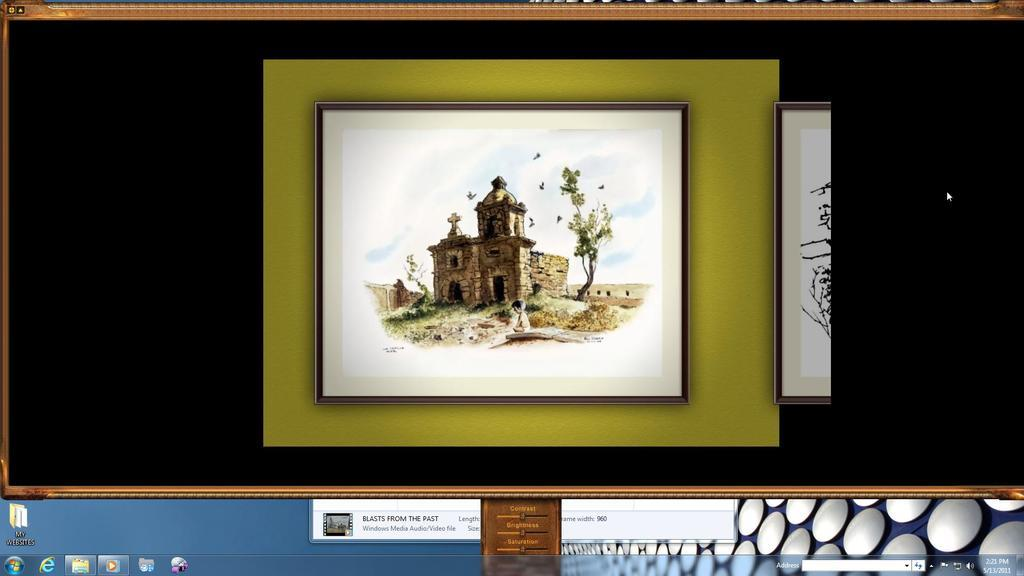What is the main object in the image? There is a computer screen in the image. What is being displayed on the computer screen? The image shows a depiction of a kid. What other elements are present in the image? There is a depiction of a building and a tree in the image. What type of coil is being used by the manager in the image? There is no manager or coil present in the image. How does the kid react to the tree in the image? The image does not show the kid's reaction to the tree, as it only depicts the kid and the tree without any indication of the kid's emotions or actions. 